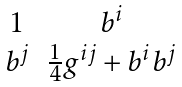Convert formula to latex. <formula><loc_0><loc_0><loc_500><loc_500>\begin{matrix} 1 & b ^ { i } \\ b ^ { j } & \frac { 1 } { 4 } g ^ { i j } + b ^ { i } b ^ { j } \\ \end{matrix}</formula> 